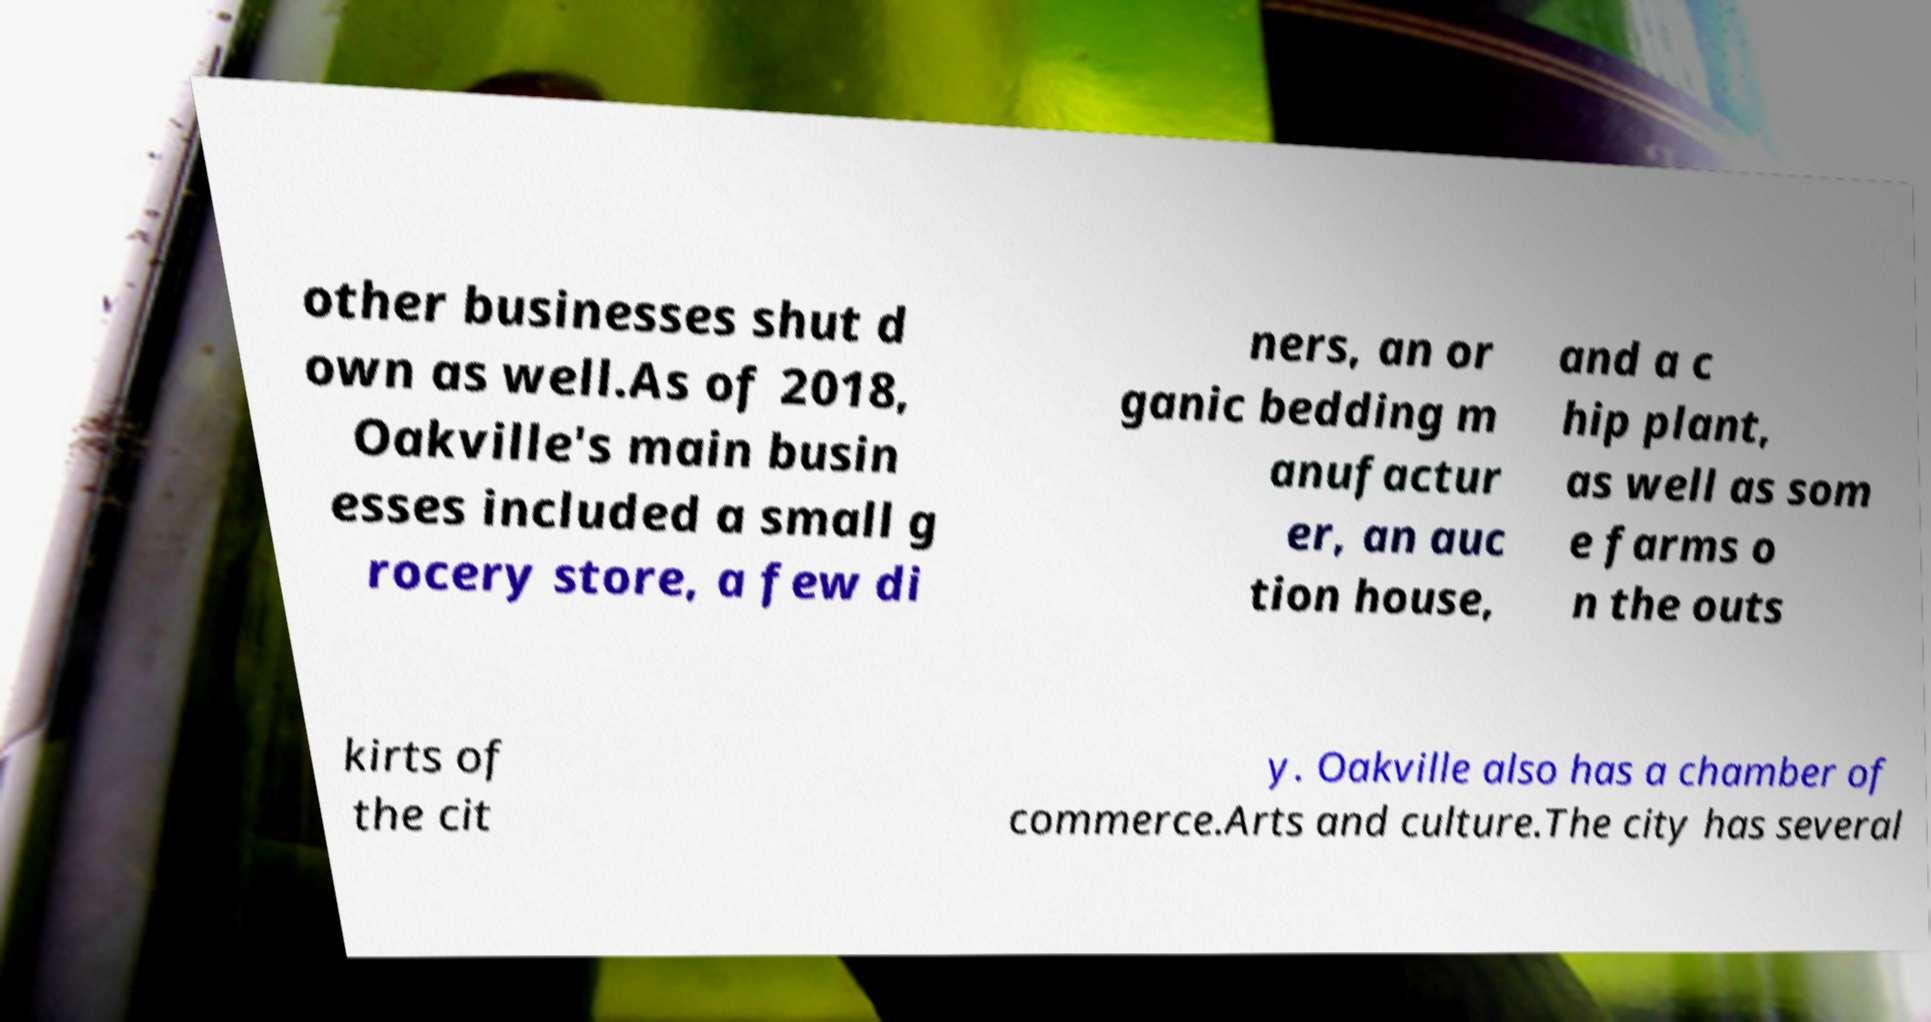Could you assist in decoding the text presented in this image and type it out clearly? other businesses shut d own as well.As of 2018, Oakville's main busin esses included a small g rocery store, a few di ners, an or ganic bedding m anufactur er, an auc tion house, and a c hip plant, as well as som e farms o n the outs kirts of the cit y. Oakville also has a chamber of commerce.Arts and culture.The city has several 